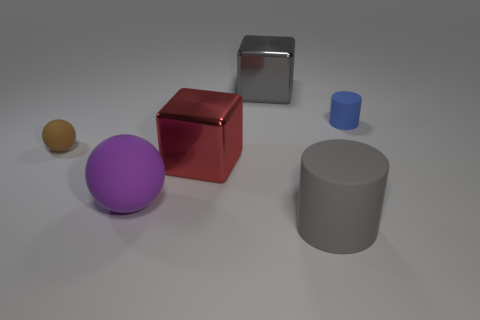Add 3 big gray metallic blocks. How many objects exist? 9 Subtract all spheres. How many objects are left? 4 Add 2 purple things. How many purple things are left? 3 Add 2 cyan matte things. How many cyan matte things exist? 2 Subtract 0 red balls. How many objects are left? 6 Subtract all blue matte cylinders. Subtract all tiny matte cylinders. How many objects are left? 4 